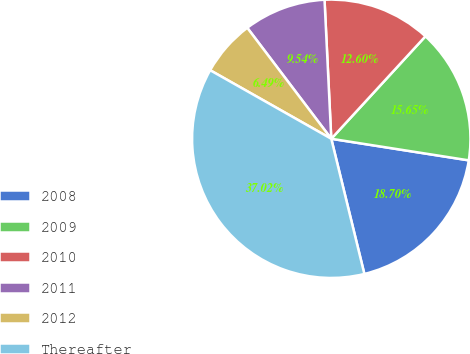<chart> <loc_0><loc_0><loc_500><loc_500><pie_chart><fcel>2008<fcel>2009<fcel>2010<fcel>2011<fcel>2012<fcel>Thereafter<nl><fcel>18.7%<fcel>15.65%<fcel>12.6%<fcel>9.54%<fcel>6.49%<fcel>37.02%<nl></chart> 